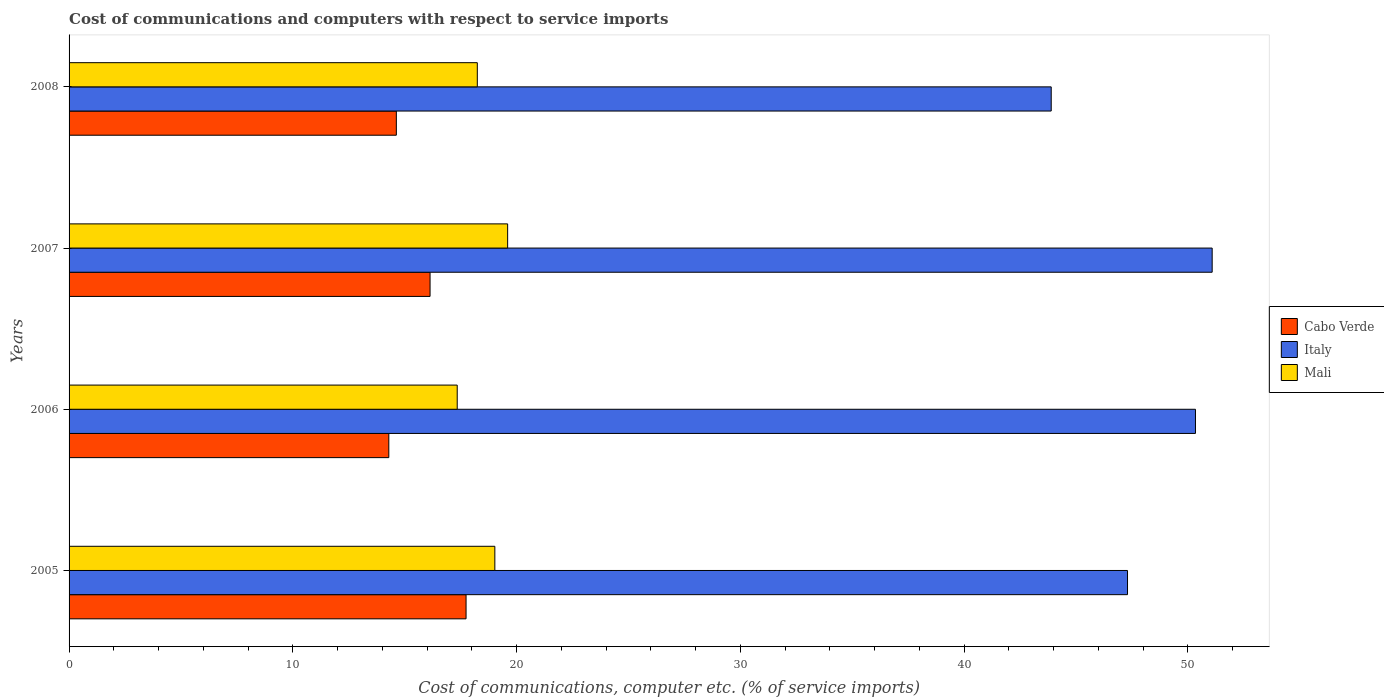Are the number of bars per tick equal to the number of legend labels?
Give a very brief answer. Yes. Are the number of bars on each tick of the Y-axis equal?
Keep it short and to the point. Yes. How many bars are there on the 2nd tick from the bottom?
Offer a very short reply. 3. What is the cost of communications and computers in Mali in 2006?
Offer a very short reply. 17.35. Across all years, what is the maximum cost of communications and computers in Cabo Verde?
Make the answer very short. 17.74. Across all years, what is the minimum cost of communications and computers in Cabo Verde?
Keep it short and to the point. 14.29. In which year was the cost of communications and computers in Cabo Verde maximum?
Keep it short and to the point. 2005. In which year was the cost of communications and computers in Mali minimum?
Your answer should be compact. 2006. What is the total cost of communications and computers in Cabo Verde in the graph?
Your response must be concise. 62.79. What is the difference between the cost of communications and computers in Italy in 2005 and that in 2007?
Give a very brief answer. -3.78. What is the difference between the cost of communications and computers in Italy in 2006 and the cost of communications and computers in Cabo Verde in 2005?
Provide a short and direct response. 32.6. What is the average cost of communications and computers in Italy per year?
Give a very brief answer. 48.15. In the year 2006, what is the difference between the cost of communications and computers in Italy and cost of communications and computers in Mali?
Offer a terse response. 32.99. In how many years, is the cost of communications and computers in Mali greater than 20 %?
Your response must be concise. 0. What is the ratio of the cost of communications and computers in Italy in 2006 to that in 2007?
Provide a short and direct response. 0.99. Is the cost of communications and computers in Italy in 2006 less than that in 2007?
Offer a terse response. Yes. Is the difference between the cost of communications and computers in Italy in 2006 and 2007 greater than the difference between the cost of communications and computers in Mali in 2006 and 2007?
Your answer should be very brief. Yes. What is the difference between the highest and the second highest cost of communications and computers in Italy?
Make the answer very short. 0.75. What is the difference between the highest and the lowest cost of communications and computers in Italy?
Offer a terse response. 7.19. In how many years, is the cost of communications and computers in Cabo Verde greater than the average cost of communications and computers in Cabo Verde taken over all years?
Ensure brevity in your answer.  2. Is the sum of the cost of communications and computers in Cabo Verde in 2005 and 2006 greater than the maximum cost of communications and computers in Mali across all years?
Ensure brevity in your answer.  Yes. What does the 2nd bar from the top in 2005 represents?
Make the answer very short. Italy. What does the 3rd bar from the bottom in 2005 represents?
Your answer should be very brief. Mali. How many bars are there?
Provide a succinct answer. 12. How many years are there in the graph?
Ensure brevity in your answer.  4. What is the difference between two consecutive major ticks on the X-axis?
Provide a succinct answer. 10. Are the values on the major ticks of X-axis written in scientific E-notation?
Provide a succinct answer. No. Does the graph contain any zero values?
Keep it short and to the point. No. Does the graph contain grids?
Your answer should be very brief. No. What is the title of the graph?
Ensure brevity in your answer.  Cost of communications and computers with respect to service imports. Does "Solomon Islands" appear as one of the legend labels in the graph?
Make the answer very short. No. What is the label or title of the X-axis?
Your answer should be very brief. Cost of communications, computer etc. (% of service imports). What is the Cost of communications, computer etc. (% of service imports) of Cabo Verde in 2005?
Your response must be concise. 17.74. What is the Cost of communications, computer etc. (% of service imports) of Italy in 2005?
Ensure brevity in your answer.  47.3. What is the Cost of communications, computer etc. (% of service imports) in Mali in 2005?
Offer a very short reply. 19.03. What is the Cost of communications, computer etc. (% of service imports) of Cabo Verde in 2006?
Keep it short and to the point. 14.29. What is the Cost of communications, computer etc. (% of service imports) of Italy in 2006?
Provide a short and direct response. 50.34. What is the Cost of communications, computer etc. (% of service imports) in Mali in 2006?
Offer a terse response. 17.35. What is the Cost of communications, computer etc. (% of service imports) in Cabo Verde in 2007?
Your response must be concise. 16.13. What is the Cost of communications, computer etc. (% of service imports) in Italy in 2007?
Ensure brevity in your answer.  51.08. What is the Cost of communications, computer etc. (% of service imports) in Mali in 2007?
Give a very brief answer. 19.6. What is the Cost of communications, computer etc. (% of service imports) in Cabo Verde in 2008?
Your answer should be very brief. 14.63. What is the Cost of communications, computer etc. (% of service imports) of Italy in 2008?
Provide a succinct answer. 43.89. What is the Cost of communications, computer etc. (% of service imports) of Mali in 2008?
Offer a terse response. 18.24. Across all years, what is the maximum Cost of communications, computer etc. (% of service imports) in Cabo Verde?
Offer a terse response. 17.74. Across all years, what is the maximum Cost of communications, computer etc. (% of service imports) in Italy?
Your answer should be compact. 51.08. Across all years, what is the maximum Cost of communications, computer etc. (% of service imports) of Mali?
Your answer should be compact. 19.6. Across all years, what is the minimum Cost of communications, computer etc. (% of service imports) of Cabo Verde?
Keep it short and to the point. 14.29. Across all years, what is the minimum Cost of communications, computer etc. (% of service imports) in Italy?
Ensure brevity in your answer.  43.89. Across all years, what is the minimum Cost of communications, computer etc. (% of service imports) of Mali?
Provide a succinct answer. 17.35. What is the total Cost of communications, computer etc. (% of service imports) of Cabo Verde in the graph?
Provide a short and direct response. 62.79. What is the total Cost of communications, computer etc. (% of service imports) in Italy in the graph?
Keep it short and to the point. 192.62. What is the total Cost of communications, computer etc. (% of service imports) in Mali in the graph?
Give a very brief answer. 74.22. What is the difference between the Cost of communications, computer etc. (% of service imports) of Cabo Verde in 2005 and that in 2006?
Ensure brevity in your answer.  3.45. What is the difference between the Cost of communications, computer etc. (% of service imports) of Italy in 2005 and that in 2006?
Ensure brevity in your answer.  -3.04. What is the difference between the Cost of communications, computer etc. (% of service imports) of Mali in 2005 and that in 2006?
Make the answer very short. 1.68. What is the difference between the Cost of communications, computer etc. (% of service imports) in Cabo Verde in 2005 and that in 2007?
Offer a very short reply. 1.61. What is the difference between the Cost of communications, computer etc. (% of service imports) in Italy in 2005 and that in 2007?
Your answer should be compact. -3.78. What is the difference between the Cost of communications, computer etc. (% of service imports) of Mali in 2005 and that in 2007?
Offer a very short reply. -0.57. What is the difference between the Cost of communications, computer etc. (% of service imports) of Cabo Verde in 2005 and that in 2008?
Make the answer very short. 3.12. What is the difference between the Cost of communications, computer etc. (% of service imports) in Italy in 2005 and that in 2008?
Offer a terse response. 3.41. What is the difference between the Cost of communications, computer etc. (% of service imports) of Mali in 2005 and that in 2008?
Make the answer very short. 0.78. What is the difference between the Cost of communications, computer etc. (% of service imports) in Cabo Verde in 2006 and that in 2007?
Offer a very short reply. -1.84. What is the difference between the Cost of communications, computer etc. (% of service imports) in Italy in 2006 and that in 2007?
Provide a short and direct response. -0.75. What is the difference between the Cost of communications, computer etc. (% of service imports) of Mali in 2006 and that in 2007?
Keep it short and to the point. -2.25. What is the difference between the Cost of communications, computer etc. (% of service imports) of Cabo Verde in 2006 and that in 2008?
Offer a very short reply. -0.34. What is the difference between the Cost of communications, computer etc. (% of service imports) of Italy in 2006 and that in 2008?
Provide a short and direct response. 6.45. What is the difference between the Cost of communications, computer etc. (% of service imports) in Mali in 2006 and that in 2008?
Your answer should be very brief. -0.9. What is the difference between the Cost of communications, computer etc. (% of service imports) of Cabo Verde in 2007 and that in 2008?
Provide a succinct answer. 1.51. What is the difference between the Cost of communications, computer etc. (% of service imports) in Italy in 2007 and that in 2008?
Ensure brevity in your answer.  7.19. What is the difference between the Cost of communications, computer etc. (% of service imports) of Mali in 2007 and that in 2008?
Your response must be concise. 1.36. What is the difference between the Cost of communications, computer etc. (% of service imports) in Cabo Verde in 2005 and the Cost of communications, computer etc. (% of service imports) in Italy in 2006?
Offer a very short reply. -32.6. What is the difference between the Cost of communications, computer etc. (% of service imports) of Cabo Verde in 2005 and the Cost of communications, computer etc. (% of service imports) of Mali in 2006?
Your response must be concise. 0.4. What is the difference between the Cost of communications, computer etc. (% of service imports) of Italy in 2005 and the Cost of communications, computer etc. (% of service imports) of Mali in 2006?
Your answer should be compact. 29.96. What is the difference between the Cost of communications, computer etc. (% of service imports) in Cabo Verde in 2005 and the Cost of communications, computer etc. (% of service imports) in Italy in 2007?
Provide a succinct answer. -33.34. What is the difference between the Cost of communications, computer etc. (% of service imports) of Cabo Verde in 2005 and the Cost of communications, computer etc. (% of service imports) of Mali in 2007?
Provide a short and direct response. -1.86. What is the difference between the Cost of communications, computer etc. (% of service imports) in Italy in 2005 and the Cost of communications, computer etc. (% of service imports) in Mali in 2007?
Offer a terse response. 27.7. What is the difference between the Cost of communications, computer etc. (% of service imports) in Cabo Verde in 2005 and the Cost of communications, computer etc. (% of service imports) in Italy in 2008?
Ensure brevity in your answer.  -26.15. What is the difference between the Cost of communications, computer etc. (% of service imports) in Cabo Verde in 2005 and the Cost of communications, computer etc. (% of service imports) in Mali in 2008?
Make the answer very short. -0.5. What is the difference between the Cost of communications, computer etc. (% of service imports) in Italy in 2005 and the Cost of communications, computer etc. (% of service imports) in Mali in 2008?
Your answer should be compact. 29.06. What is the difference between the Cost of communications, computer etc. (% of service imports) in Cabo Verde in 2006 and the Cost of communications, computer etc. (% of service imports) in Italy in 2007?
Keep it short and to the point. -36.8. What is the difference between the Cost of communications, computer etc. (% of service imports) in Cabo Verde in 2006 and the Cost of communications, computer etc. (% of service imports) in Mali in 2007?
Provide a succinct answer. -5.31. What is the difference between the Cost of communications, computer etc. (% of service imports) of Italy in 2006 and the Cost of communications, computer etc. (% of service imports) of Mali in 2007?
Keep it short and to the point. 30.74. What is the difference between the Cost of communications, computer etc. (% of service imports) of Cabo Verde in 2006 and the Cost of communications, computer etc. (% of service imports) of Italy in 2008?
Your response must be concise. -29.6. What is the difference between the Cost of communications, computer etc. (% of service imports) in Cabo Verde in 2006 and the Cost of communications, computer etc. (% of service imports) in Mali in 2008?
Give a very brief answer. -3.95. What is the difference between the Cost of communications, computer etc. (% of service imports) in Italy in 2006 and the Cost of communications, computer etc. (% of service imports) in Mali in 2008?
Your response must be concise. 32.09. What is the difference between the Cost of communications, computer etc. (% of service imports) in Cabo Verde in 2007 and the Cost of communications, computer etc. (% of service imports) in Italy in 2008?
Provide a succinct answer. -27.76. What is the difference between the Cost of communications, computer etc. (% of service imports) in Cabo Verde in 2007 and the Cost of communications, computer etc. (% of service imports) in Mali in 2008?
Your answer should be compact. -2.11. What is the difference between the Cost of communications, computer etc. (% of service imports) of Italy in 2007 and the Cost of communications, computer etc. (% of service imports) of Mali in 2008?
Make the answer very short. 32.84. What is the average Cost of communications, computer etc. (% of service imports) in Cabo Verde per year?
Provide a succinct answer. 15.7. What is the average Cost of communications, computer etc. (% of service imports) of Italy per year?
Provide a short and direct response. 48.15. What is the average Cost of communications, computer etc. (% of service imports) in Mali per year?
Make the answer very short. 18.55. In the year 2005, what is the difference between the Cost of communications, computer etc. (% of service imports) of Cabo Verde and Cost of communications, computer etc. (% of service imports) of Italy?
Make the answer very short. -29.56. In the year 2005, what is the difference between the Cost of communications, computer etc. (% of service imports) in Cabo Verde and Cost of communications, computer etc. (% of service imports) in Mali?
Offer a terse response. -1.29. In the year 2005, what is the difference between the Cost of communications, computer etc. (% of service imports) of Italy and Cost of communications, computer etc. (% of service imports) of Mali?
Give a very brief answer. 28.27. In the year 2006, what is the difference between the Cost of communications, computer etc. (% of service imports) of Cabo Verde and Cost of communications, computer etc. (% of service imports) of Italy?
Provide a succinct answer. -36.05. In the year 2006, what is the difference between the Cost of communications, computer etc. (% of service imports) of Cabo Verde and Cost of communications, computer etc. (% of service imports) of Mali?
Ensure brevity in your answer.  -3.06. In the year 2006, what is the difference between the Cost of communications, computer etc. (% of service imports) in Italy and Cost of communications, computer etc. (% of service imports) in Mali?
Ensure brevity in your answer.  32.99. In the year 2007, what is the difference between the Cost of communications, computer etc. (% of service imports) of Cabo Verde and Cost of communications, computer etc. (% of service imports) of Italy?
Offer a very short reply. -34.95. In the year 2007, what is the difference between the Cost of communications, computer etc. (% of service imports) of Cabo Verde and Cost of communications, computer etc. (% of service imports) of Mali?
Your response must be concise. -3.47. In the year 2007, what is the difference between the Cost of communications, computer etc. (% of service imports) of Italy and Cost of communications, computer etc. (% of service imports) of Mali?
Offer a very short reply. 31.49. In the year 2008, what is the difference between the Cost of communications, computer etc. (% of service imports) in Cabo Verde and Cost of communications, computer etc. (% of service imports) in Italy?
Provide a succinct answer. -29.27. In the year 2008, what is the difference between the Cost of communications, computer etc. (% of service imports) in Cabo Verde and Cost of communications, computer etc. (% of service imports) in Mali?
Your response must be concise. -3.62. In the year 2008, what is the difference between the Cost of communications, computer etc. (% of service imports) of Italy and Cost of communications, computer etc. (% of service imports) of Mali?
Your answer should be very brief. 25.65. What is the ratio of the Cost of communications, computer etc. (% of service imports) in Cabo Verde in 2005 to that in 2006?
Your response must be concise. 1.24. What is the ratio of the Cost of communications, computer etc. (% of service imports) of Italy in 2005 to that in 2006?
Give a very brief answer. 0.94. What is the ratio of the Cost of communications, computer etc. (% of service imports) in Mali in 2005 to that in 2006?
Your answer should be compact. 1.1. What is the ratio of the Cost of communications, computer etc. (% of service imports) of Cabo Verde in 2005 to that in 2007?
Provide a short and direct response. 1.1. What is the ratio of the Cost of communications, computer etc. (% of service imports) in Italy in 2005 to that in 2007?
Your answer should be very brief. 0.93. What is the ratio of the Cost of communications, computer etc. (% of service imports) of Mali in 2005 to that in 2007?
Offer a very short reply. 0.97. What is the ratio of the Cost of communications, computer etc. (% of service imports) of Cabo Verde in 2005 to that in 2008?
Make the answer very short. 1.21. What is the ratio of the Cost of communications, computer etc. (% of service imports) of Italy in 2005 to that in 2008?
Your answer should be compact. 1.08. What is the ratio of the Cost of communications, computer etc. (% of service imports) of Mali in 2005 to that in 2008?
Ensure brevity in your answer.  1.04. What is the ratio of the Cost of communications, computer etc. (% of service imports) in Cabo Verde in 2006 to that in 2007?
Offer a terse response. 0.89. What is the ratio of the Cost of communications, computer etc. (% of service imports) in Italy in 2006 to that in 2007?
Make the answer very short. 0.99. What is the ratio of the Cost of communications, computer etc. (% of service imports) in Mali in 2006 to that in 2007?
Ensure brevity in your answer.  0.89. What is the ratio of the Cost of communications, computer etc. (% of service imports) of Cabo Verde in 2006 to that in 2008?
Your answer should be very brief. 0.98. What is the ratio of the Cost of communications, computer etc. (% of service imports) in Italy in 2006 to that in 2008?
Keep it short and to the point. 1.15. What is the ratio of the Cost of communications, computer etc. (% of service imports) of Mali in 2006 to that in 2008?
Your answer should be very brief. 0.95. What is the ratio of the Cost of communications, computer etc. (% of service imports) of Cabo Verde in 2007 to that in 2008?
Make the answer very short. 1.1. What is the ratio of the Cost of communications, computer etc. (% of service imports) in Italy in 2007 to that in 2008?
Your answer should be compact. 1.16. What is the ratio of the Cost of communications, computer etc. (% of service imports) in Mali in 2007 to that in 2008?
Give a very brief answer. 1.07. What is the difference between the highest and the second highest Cost of communications, computer etc. (% of service imports) in Cabo Verde?
Give a very brief answer. 1.61. What is the difference between the highest and the second highest Cost of communications, computer etc. (% of service imports) of Italy?
Your answer should be very brief. 0.75. What is the difference between the highest and the second highest Cost of communications, computer etc. (% of service imports) of Mali?
Keep it short and to the point. 0.57. What is the difference between the highest and the lowest Cost of communications, computer etc. (% of service imports) in Cabo Verde?
Your answer should be very brief. 3.45. What is the difference between the highest and the lowest Cost of communications, computer etc. (% of service imports) in Italy?
Keep it short and to the point. 7.19. What is the difference between the highest and the lowest Cost of communications, computer etc. (% of service imports) of Mali?
Your answer should be very brief. 2.25. 